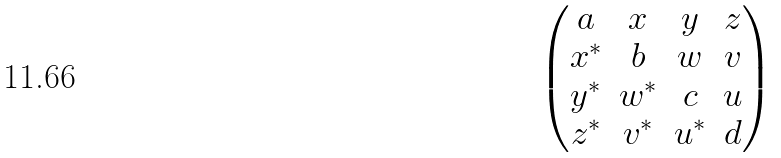<formula> <loc_0><loc_0><loc_500><loc_500>\begin{pmatrix} a & x & y & z \\ x ^ { * } & b & w & v \\ y ^ { * } & w ^ { * } & c & u \\ z ^ { * } & v ^ { * } & u ^ { * } & d \end{pmatrix}</formula> 